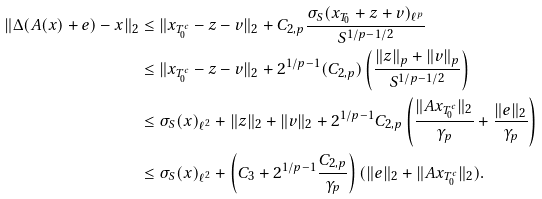Convert formula to latex. <formula><loc_0><loc_0><loc_500><loc_500>\| \Delta ( { A ( x ) + e } ) - { x } \| _ { 2 } & \leq \| { x _ { T _ { 0 } ^ { c } } - z - v } \| _ { 2 } + C _ { 2 , p } \frac { \sigma _ { S } ( { x _ { T _ { 0 } } + z + v } ) _ { \ell ^ { p } } } { S ^ { 1 / p - 1 / 2 } } \\ & \leq \| { x _ { T _ { 0 } ^ { c } } - z - v } \| _ { 2 } + 2 ^ { 1 / p - 1 } ( C _ { 2 , p } ) \left ( \frac { \| { z } \| _ { p } + \| { v } \| _ { p } } { S ^ { 1 / p - 1 / 2 } } \right ) \\ & \leq { \sigma _ { S } ( { x } ) } _ { \ell ^ { 2 } } + \| { z } \| _ { 2 } + \| { v } \| _ { 2 } + 2 ^ { 1 / p - 1 } C _ { 2 , p } \left ( { \frac { \| { A x _ { T _ { 0 } ^ { c } } } \| _ { 2 } } { \gamma _ { p } } + \frac { \| { e } \| _ { 2 } } { \gamma _ { p } } } \right ) \\ & \leq { \sigma _ { S } ( { x } ) } _ { \ell ^ { 2 } } + \left ( C _ { 3 } + 2 ^ { 1 / p - 1 } \frac { C _ { 2 , p } } { \gamma _ { p } } \right ) ( \| { e } \| _ { 2 } + \| { A x _ { T _ { 0 } ^ { c } } } \| _ { 2 } ) .</formula> 